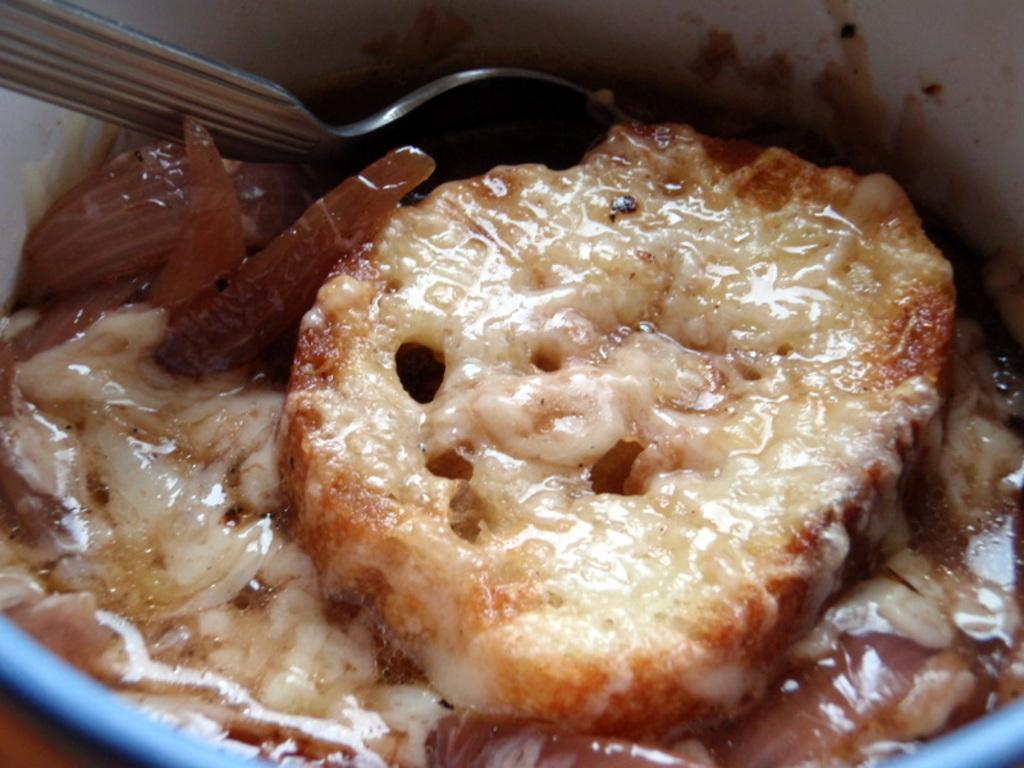What is in the bowl that is visible in the image? There are sweets in a bowl in the image. Where is the spoon located in the image? The spoon is in the top left corner of the image. What type of slope can be seen in the image? There is no slope present in the image. How are the hands being used in the image? There are no hands visible in the image. 